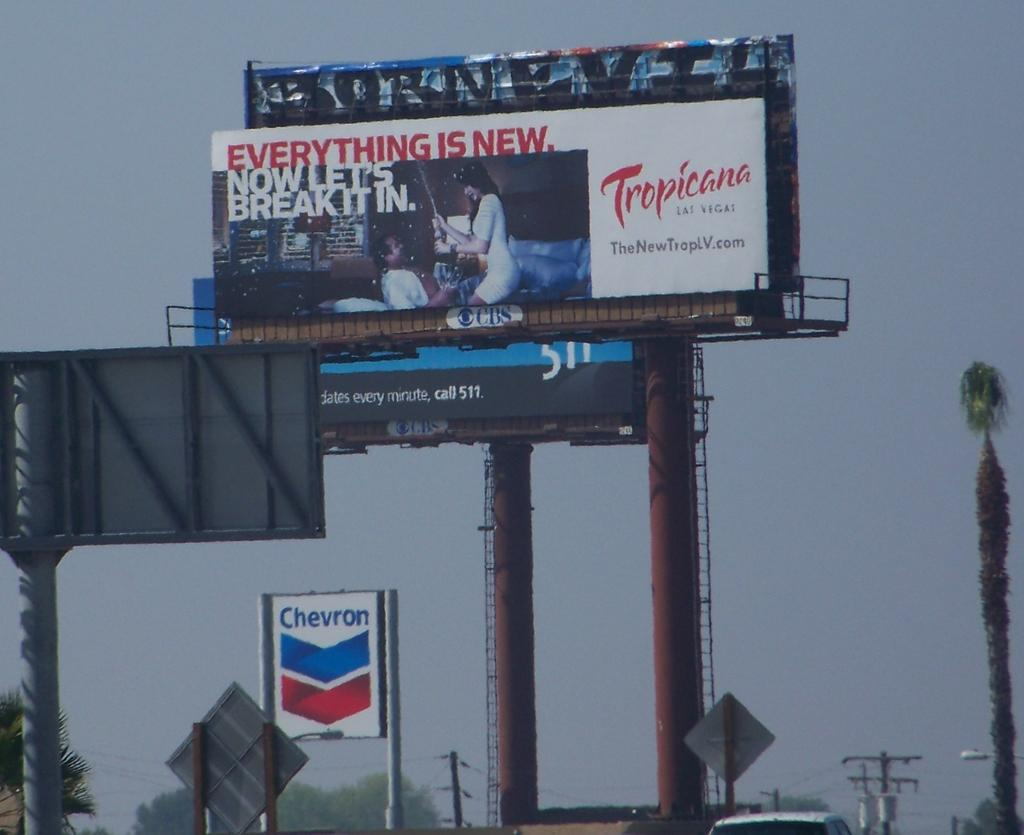<image>
Give a short and clear explanation of the subsequent image. A billboard with an add for the Tropicana Hotel 